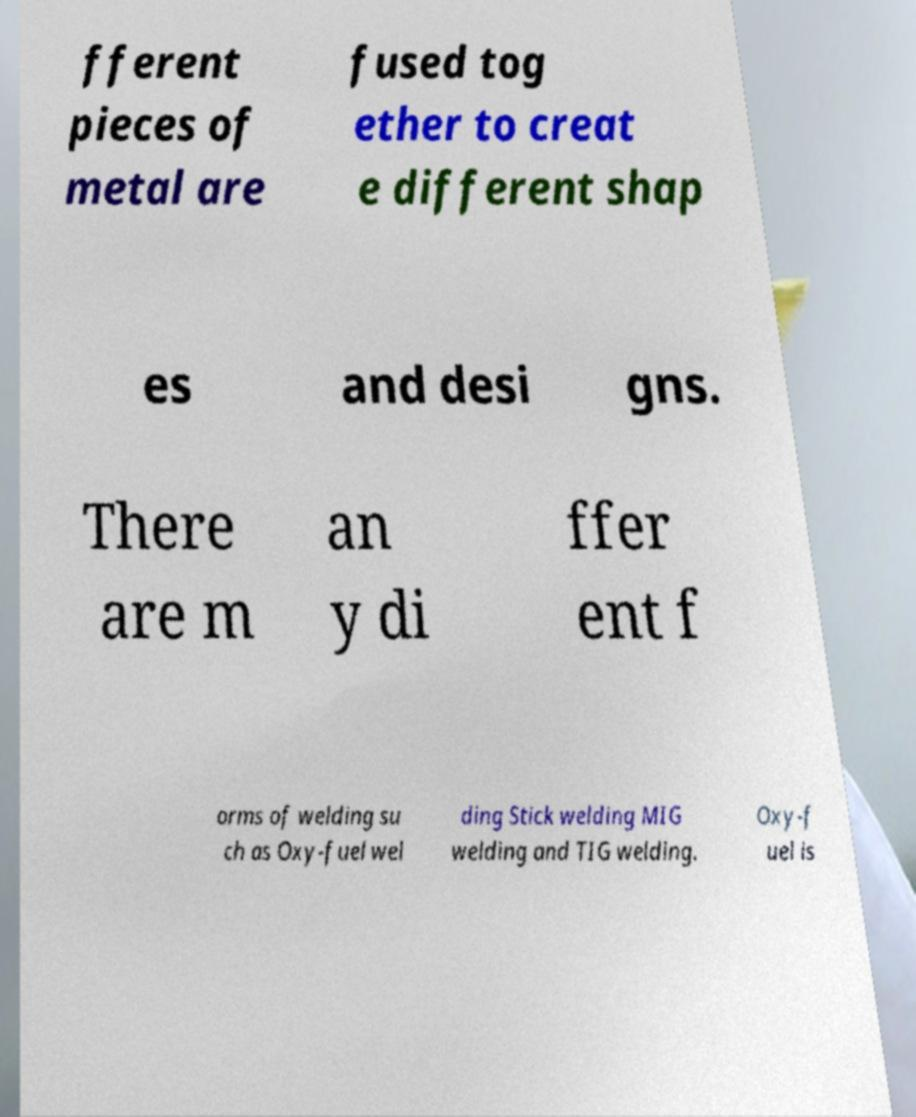What messages or text are displayed in this image? I need them in a readable, typed format. fferent pieces of metal are fused tog ether to creat e different shap es and desi gns. There are m an y di ffer ent f orms of welding su ch as Oxy-fuel wel ding Stick welding MIG welding and TIG welding. Oxy-f uel is 